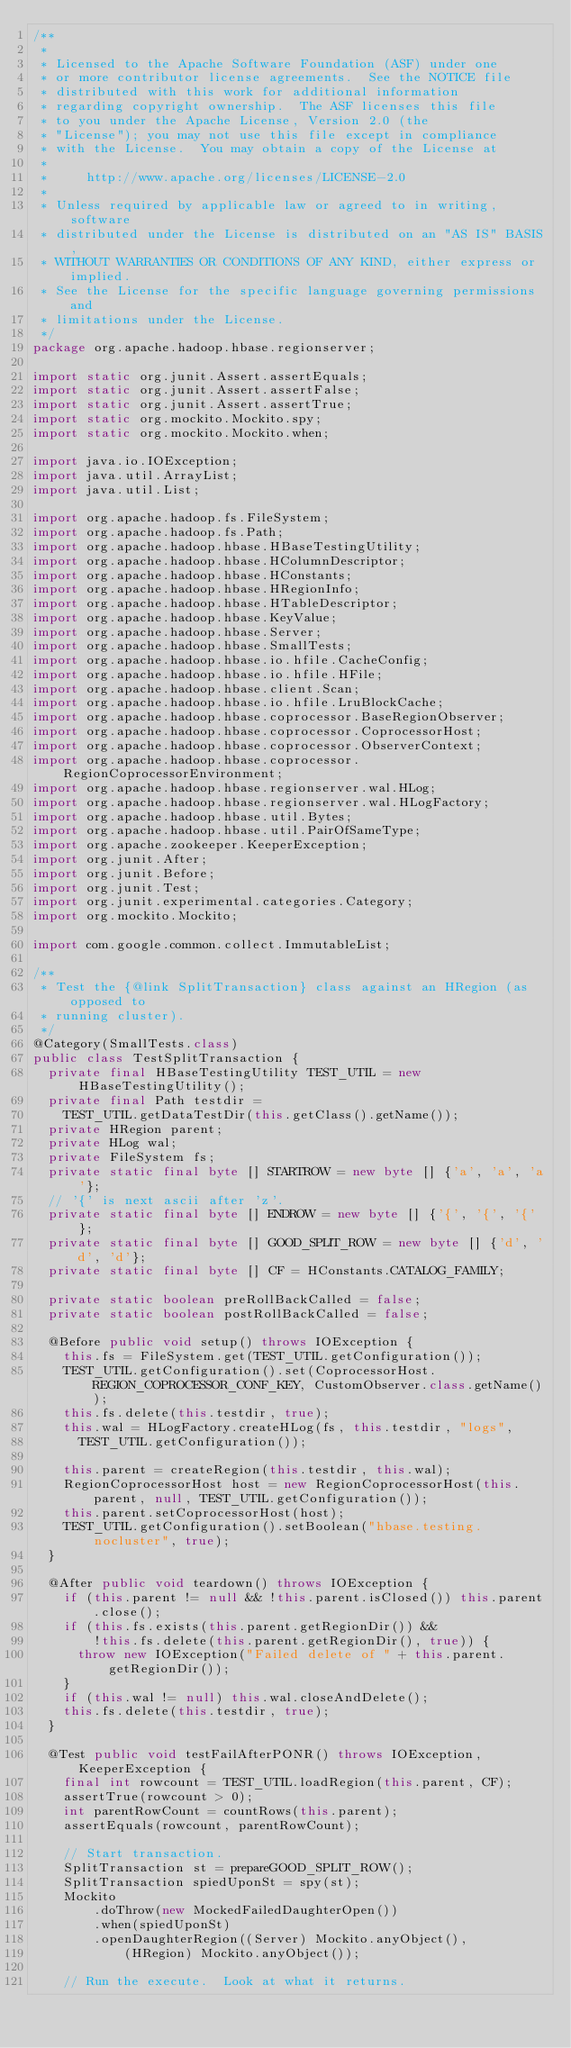<code> <loc_0><loc_0><loc_500><loc_500><_Java_>/**
 *
 * Licensed to the Apache Software Foundation (ASF) under one
 * or more contributor license agreements.  See the NOTICE file
 * distributed with this work for additional information
 * regarding copyright ownership.  The ASF licenses this file
 * to you under the Apache License, Version 2.0 (the
 * "License"); you may not use this file except in compliance
 * with the License.  You may obtain a copy of the License at
 *
 *     http://www.apache.org/licenses/LICENSE-2.0
 *
 * Unless required by applicable law or agreed to in writing, software
 * distributed under the License is distributed on an "AS IS" BASIS,
 * WITHOUT WARRANTIES OR CONDITIONS OF ANY KIND, either express or implied.
 * See the License for the specific language governing permissions and
 * limitations under the License.
 */
package org.apache.hadoop.hbase.regionserver;

import static org.junit.Assert.assertEquals;
import static org.junit.Assert.assertFalse;
import static org.junit.Assert.assertTrue;
import static org.mockito.Mockito.spy;
import static org.mockito.Mockito.when;

import java.io.IOException;
import java.util.ArrayList;
import java.util.List;

import org.apache.hadoop.fs.FileSystem;
import org.apache.hadoop.fs.Path;
import org.apache.hadoop.hbase.HBaseTestingUtility;
import org.apache.hadoop.hbase.HColumnDescriptor;
import org.apache.hadoop.hbase.HConstants;
import org.apache.hadoop.hbase.HRegionInfo;
import org.apache.hadoop.hbase.HTableDescriptor;
import org.apache.hadoop.hbase.KeyValue;
import org.apache.hadoop.hbase.Server;
import org.apache.hadoop.hbase.SmallTests;
import org.apache.hadoop.hbase.io.hfile.CacheConfig;
import org.apache.hadoop.hbase.io.hfile.HFile;
import org.apache.hadoop.hbase.client.Scan;
import org.apache.hadoop.hbase.io.hfile.LruBlockCache;
import org.apache.hadoop.hbase.coprocessor.BaseRegionObserver;
import org.apache.hadoop.hbase.coprocessor.CoprocessorHost;
import org.apache.hadoop.hbase.coprocessor.ObserverContext;
import org.apache.hadoop.hbase.coprocessor.RegionCoprocessorEnvironment;
import org.apache.hadoop.hbase.regionserver.wal.HLog;
import org.apache.hadoop.hbase.regionserver.wal.HLogFactory;
import org.apache.hadoop.hbase.util.Bytes;
import org.apache.hadoop.hbase.util.PairOfSameType;
import org.apache.zookeeper.KeeperException;
import org.junit.After;
import org.junit.Before;
import org.junit.Test;
import org.junit.experimental.categories.Category;
import org.mockito.Mockito;

import com.google.common.collect.ImmutableList;

/**
 * Test the {@link SplitTransaction} class against an HRegion (as opposed to
 * running cluster).
 */
@Category(SmallTests.class)
public class TestSplitTransaction {
  private final HBaseTestingUtility TEST_UTIL = new HBaseTestingUtility();
  private final Path testdir =
    TEST_UTIL.getDataTestDir(this.getClass().getName());
  private HRegion parent;
  private HLog wal;
  private FileSystem fs;
  private static final byte [] STARTROW = new byte [] {'a', 'a', 'a'};
  // '{' is next ascii after 'z'.
  private static final byte [] ENDROW = new byte [] {'{', '{', '{'};
  private static final byte [] GOOD_SPLIT_ROW = new byte [] {'d', 'd', 'd'};
  private static final byte [] CF = HConstants.CATALOG_FAMILY;
  
  private static boolean preRollBackCalled = false;
  private static boolean postRollBackCalled = false;
  
  @Before public void setup() throws IOException {
    this.fs = FileSystem.get(TEST_UTIL.getConfiguration());
    TEST_UTIL.getConfiguration().set(CoprocessorHost.REGION_COPROCESSOR_CONF_KEY, CustomObserver.class.getName());
    this.fs.delete(this.testdir, true);
    this.wal = HLogFactory.createHLog(fs, this.testdir, "logs",
      TEST_UTIL.getConfiguration());
    
    this.parent = createRegion(this.testdir, this.wal);
    RegionCoprocessorHost host = new RegionCoprocessorHost(this.parent, null, TEST_UTIL.getConfiguration());
    this.parent.setCoprocessorHost(host);
    TEST_UTIL.getConfiguration().setBoolean("hbase.testing.nocluster", true);
  }

  @After public void teardown() throws IOException {
    if (this.parent != null && !this.parent.isClosed()) this.parent.close();
    if (this.fs.exists(this.parent.getRegionDir()) &&
        !this.fs.delete(this.parent.getRegionDir(), true)) {
      throw new IOException("Failed delete of " + this.parent.getRegionDir());
    }
    if (this.wal != null) this.wal.closeAndDelete();
    this.fs.delete(this.testdir, true);
  }

  @Test public void testFailAfterPONR() throws IOException, KeeperException {
    final int rowcount = TEST_UTIL.loadRegion(this.parent, CF);
    assertTrue(rowcount > 0);
    int parentRowCount = countRows(this.parent);
    assertEquals(rowcount, parentRowCount);

    // Start transaction.
    SplitTransaction st = prepareGOOD_SPLIT_ROW();
    SplitTransaction spiedUponSt = spy(st);
    Mockito
        .doThrow(new MockedFailedDaughterOpen())
        .when(spiedUponSt)
        .openDaughterRegion((Server) Mockito.anyObject(),
            (HRegion) Mockito.anyObject());

    // Run the execute.  Look at what it returns.</code> 